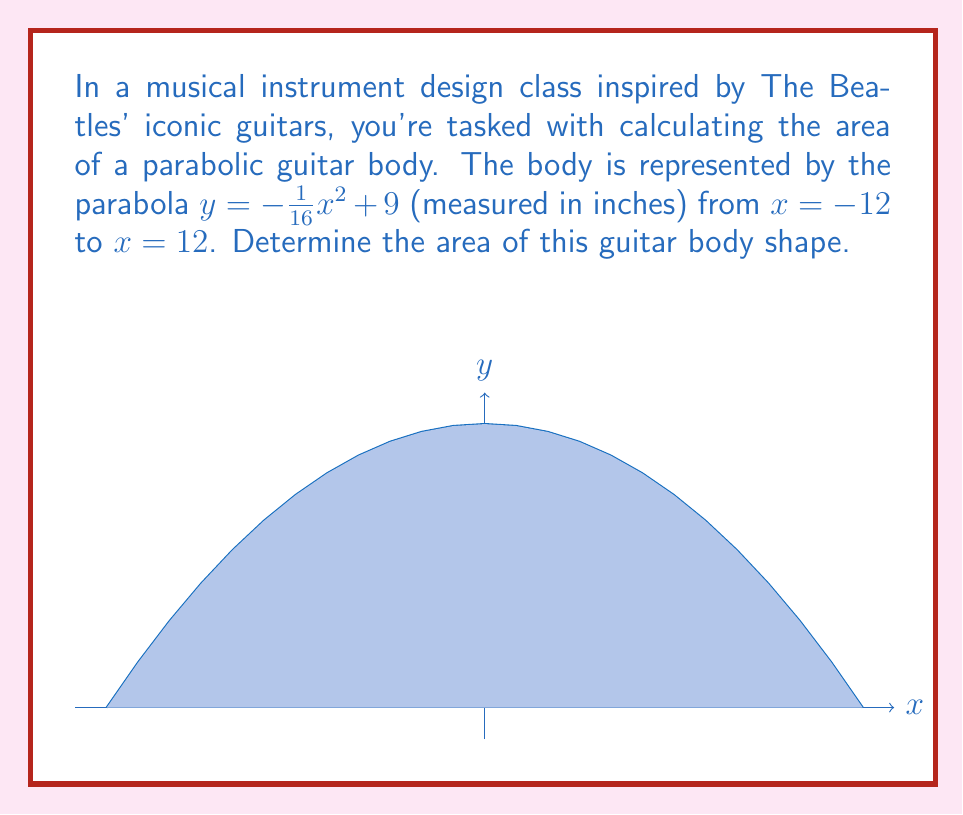Show me your answer to this math problem. Let's approach this step-by-step:

1) The area under a parabola can be found using the formula:

   $$ A = \int_{a}^{b} [f(x) - g(x)] dx $$

   where $f(x)$ is our parabola and $g(x)$ is the lower bound (in this case, the x-axis).

2) Our parabola is $f(x) = -\frac{1}{16}x^2 + 9$, and we're integrating from $a = -12$ to $b = 12$.

3) Set up the integral:

   $$ A = \int_{-12}^{12} (-\frac{1}{16}x^2 + 9) dx $$

4) Integrate:

   $$ A = [-\frac{1}{48}x^3 + 9x]_{-12}^{12} $$

5) Evaluate the integral:

   $$ A = (-\frac{1}{48}(12^3) + 9(12)) - (-\frac{1}{48}(-12^3) + 9(-12)) $$

6) Simplify:

   $$ A = (-36 + 108) - (36 - 108) $$
   $$ A = 72 + 72 = 144 $$

Therefore, the area of the guitar body is 144 square inches.
Answer: 144 square inches 